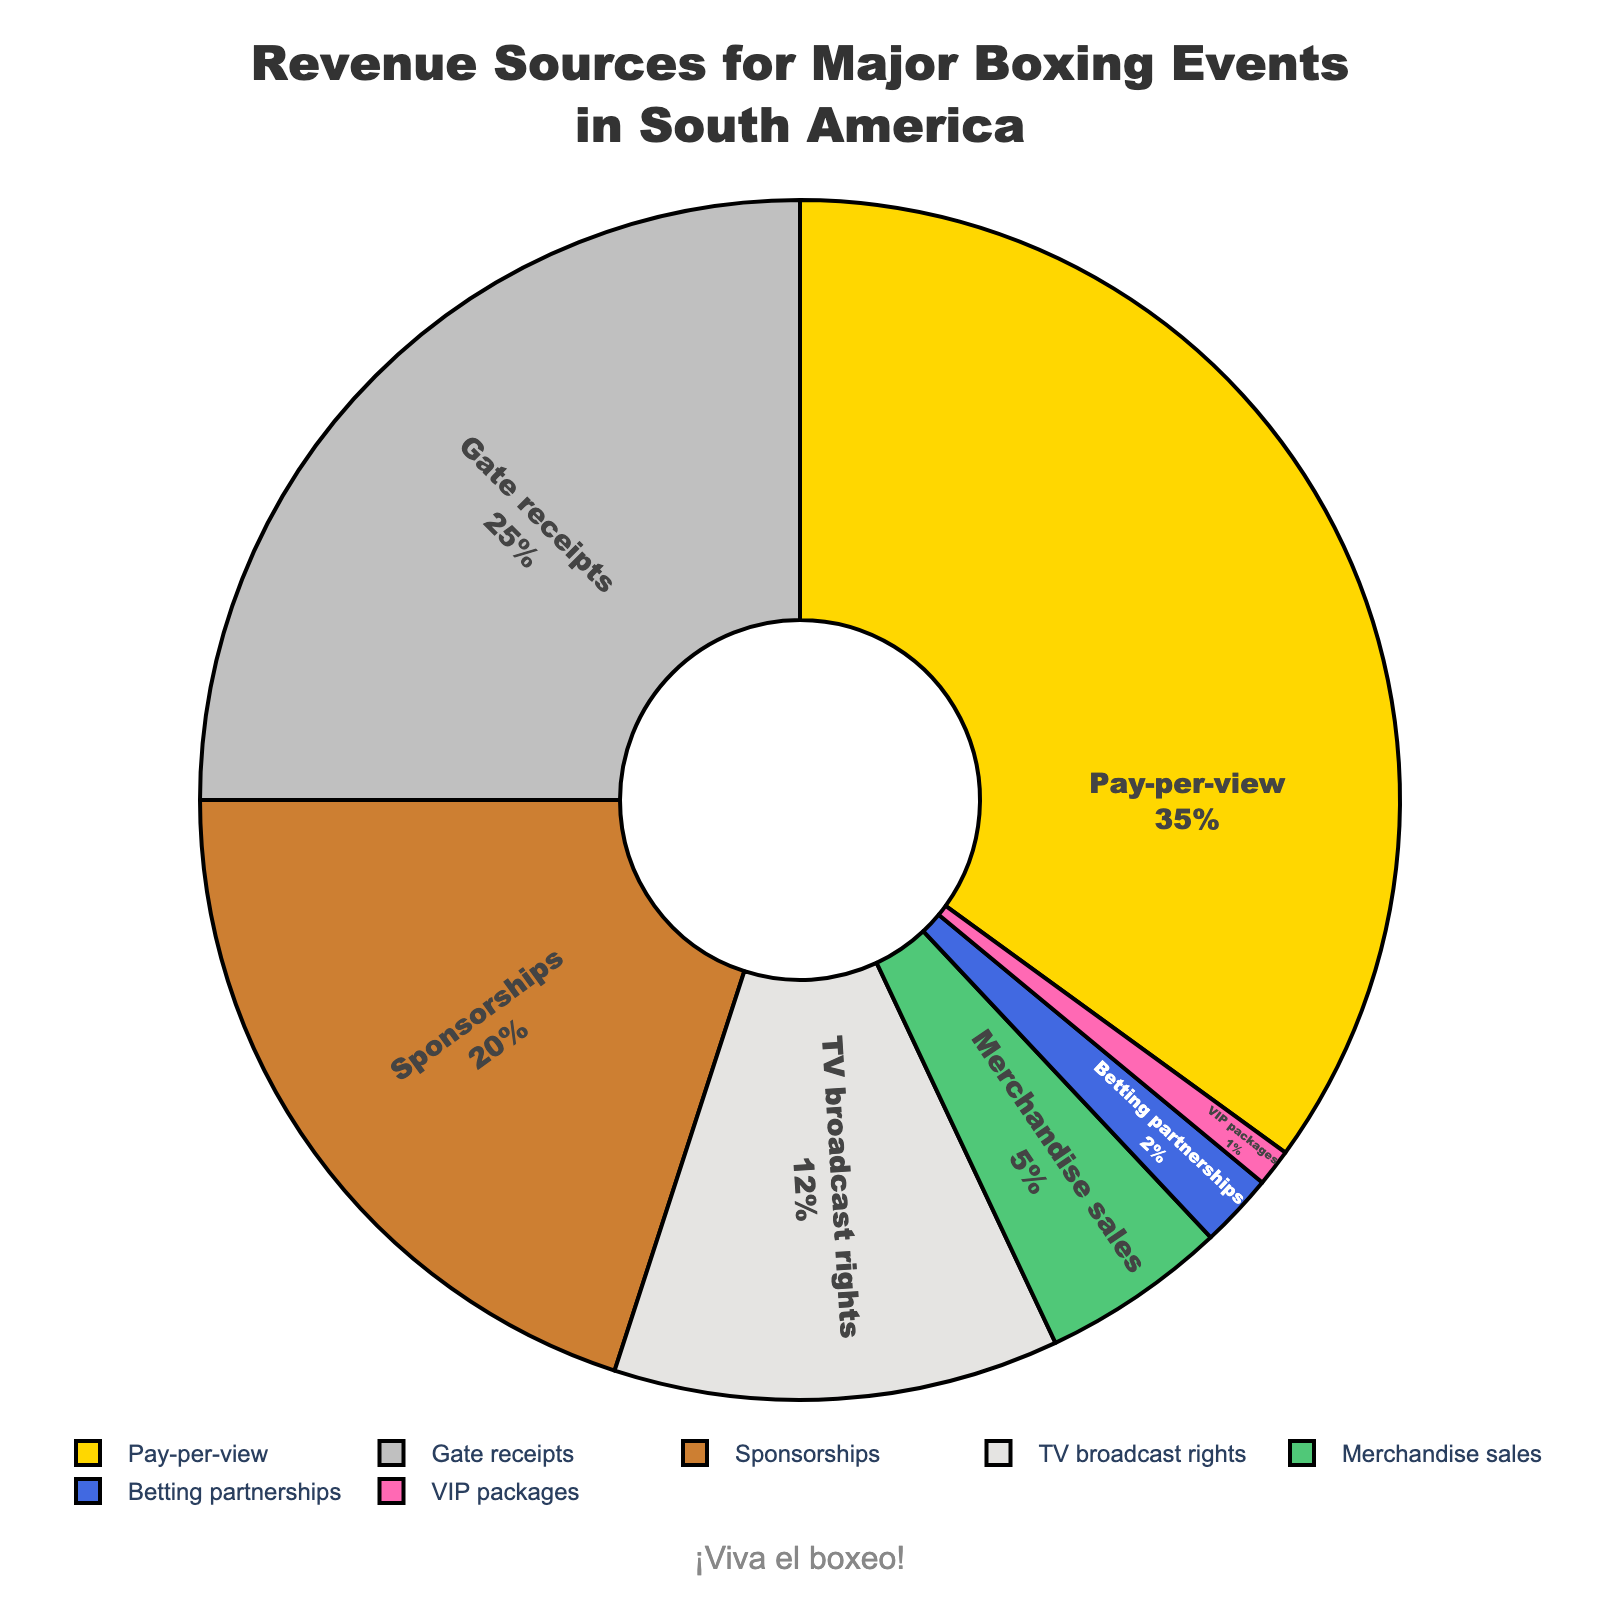Which revenue source contributes the most to the total revenue? Pay-per-view has the largest slice of the pie with a percentage of 35%, making it the highest contributor.
Answer: Pay-per-view Which two revenue sources combined contribute to more than 50% of the total revenue? Pay-per-view contributes 35% and Gate receipts contribute 25%. Combined, they contribute 35% + 25% = 60%, which is more than 50%.
Answer: Pay-per-view and Gate receipts What is the difference in revenue contribution between Pay-per-view and Sponsorships? Pay-per-view contributes 35% and Sponsorships contribute 20%. The difference is 35% - 20% = 15%.
Answer: 15% How much percentage of revenue is contributed by the smallest segment? VIP packages are the smallest segment, contributing 1% of the total revenue.
Answer: 1% Which revenue segments contribute less than 10% each to the total revenue? Merchandise sales contribute 5%, Betting partnerships 2%, and VIP packages 1%. All these segments contribute less than 10% each.
Answer: Merchandise sales, Betting partnerships, VIP packages What is the combined percentage of revenue from Merchandise sales, Betting partnerships, and VIP packages? Merchandise sales contribute 5%, Betting partnerships 2%, and VIP packages 1%. Combined, they contribute 5% + 2% +1% = 8%.
Answer: 8% How much more does TV broadcast rights contribute to the revenue compared to Merchandise sales? TV broadcast rights contribute 12% and Merchandise sales contribute 5%. The difference is 12% - 5% = 7%.
Answer: 7% Which segment has the same visual color as the second-largest segment? Gate receipts, the second-largest segment, is represented in silver color.
Answer: Gate receipts What revenue sources contribute to less than 20% each but more than 5%? Sponsorships contribute 20% and TV broadcast rights contribute 12%. Both are less than 20% and more than 5%.
Answer: Sponsorships, TV broadcast rights 